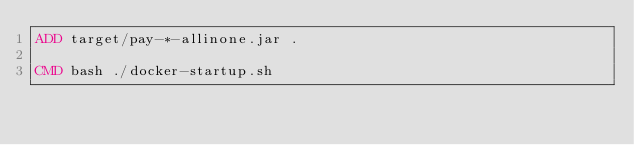<code> <loc_0><loc_0><loc_500><loc_500><_Dockerfile_>ADD target/pay-*-allinone.jar .

CMD bash ./docker-startup.sh
</code> 